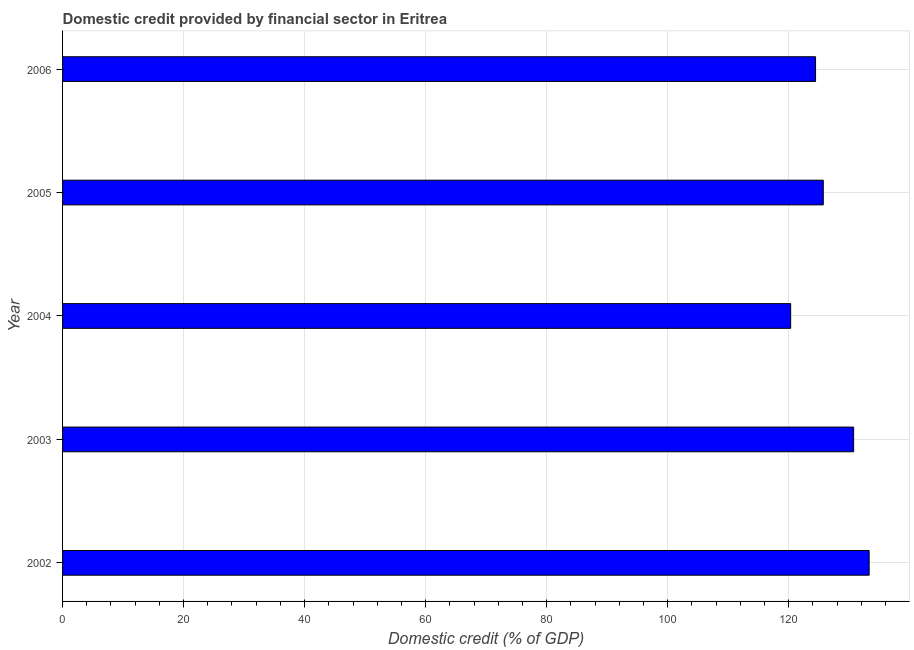Does the graph contain any zero values?
Give a very brief answer. No. Does the graph contain grids?
Your answer should be compact. Yes. What is the title of the graph?
Give a very brief answer. Domestic credit provided by financial sector in Eritrea. What is the label or title of the X-axis?
Your answer should be compact. Domestic credit (% of GDP). What is the domestic credit provided by financial sector in 2004?
Give a very brief answer. 120.34. Across all years, what is the maximum domestic credit provided by financial sector?
Provide a short and direct response. 133.31. Across all years, what is the minimum domestic credit provided by financial sector?
Give a very brief answer. 120.34. What is the sum of the domestic credit provided by financial sector?
Give a very brief answer. 634.56. What is the difference between the domestic credit provided by financial sector in 2003 and 2006?
Give a very brief answer. 6.29. What is the average domestic credit provided by financial sector per year?
Provide a succinct answer. 126.91. What is the median domestic credit provided by financial sector?
Your response must be concise. 125.73. In how many years, is the domestic credit provided by financial sector greater than 24 %?
Give a very brief answer. 5. What is the ratio of the domestic credit provided by financial sector in 2004 to that in 2006?
Provide a succinct answer. 0.97. Is the difference between the domestic credit provided by financial sector in 2003 and 2005 greater than the difference between any two years?
Keep it short and to the point. No. What is the difference between the highest and the second highest domestic credit provided by financial sector?
Provide a succinct answer. 2.56. Is the sum of the domestic credit provided by financial sector in 2004 and 2005 greater than the maximum domestic credit provided by financial sector across all years?
Give a very brief answer. Yes. What is the difference between the highest and the lowest domestic credit provided by financial sector?
Your answer should be very brief. 12.97. Are all the bars in the graph horizontal?
Ensure brevity in your answer.  Yes. How many years are there in the graph?
Offer a very short reply. 5. What is the difference between two consecutive major ticks on the X-axis?
Your answer should be very brief. 20. Are the values on the major ticks of X-axis written in scientific E-notation?
Provide a short and direct response. No. What is the Domestic credit (% of GDP) in 2002?
Give a very brief answer. 133.31. What is the Domestic credit (% of GDP) in 2003?
Your answer should be very brief. 130.74. What is the Domestic credit (% of GDP) of 2004?
Offer a terse response. 120.34. What is the Domestic credit (% of GDP) in 2005?
Make the answer very short. 125.73. What is the Domestic credit (% of GDP) of 2006?
Provide a succinct answer. 124.45. What is the difference between the Domestic credit (% of GDP) in 2002 and 2003?
Offer a very short reply. 2.56. What is the difference between the Domestic credit (% of GDP) in 2002 and 2004?
Ensure brevity in your answer.  12.97. What is the difference between the Domestic credit (% of GDP) in 2002 and 2005?
Provide a short and direct response. 7.58. What is the difference between the Domestic credit (% of GDP) in 2002 and 2006?
Your answer should be very brief. 8.86. What is the difference between the Domestic credit (% of GDP) in 2003 and 2004?
Give a very brief answer. 10.41. What is the difference between the Domestic credit (% of GDP) in 2003 and 2005?
Your answer should be compact. 5.02. What is the difference between the Domestic credit (% of GDP) in 2003 and 2006?
Your response must be concise. 6.29. What is the difference between the Domestic credit (% of GDP) in 2004 and 2005?
Provide a short and direct response. -5.39. What is the difference between the Domestic credit (% of GDP) in 2004 and 2006?
Give a very brief answer. -4.11. What is the difference between the Domestic credit (% of GDP) in 2005 and 2006?
Ensure brevity in your answer.  1.28. What is the ratio of the Domestic credit (% of GDP) in 2002 to that in 2003?
Make the answer very short. 1.02. What is the ratio of the Domestic credit (% of GDP) in 2002 to that in 2004?
Your answer should be compact. 1.11. What is the ratio of the Domestic credit (% of GDP) in 2002 to that in 2005?
Make the answer very short. 1.06. What is the ratio of the Domestic credit (% of GDP) in 2002 to that in 2006?
Provide a succinct answer. 1.07. What is the ratio of the Domestic credit (% of GDP) in 2003 to that in 2004?
Provide a succinct answer. 1.09. What is the ratio of the Domestic credit (% of GDP) in 2003 to that in 2005?
Make the answer very short. 1.04. What is the ratio of the Domestic credit (% of GDP) in 2003 to that in 2006?
Offer a very short reply. 1.05. What is the ratio of the Domestic credit (% of GDP) in 2004 to that in 2005?
Give a very brief answer. 0.96. What is the ratio of the Domestic credit (% of GDP) in 2004 to that in 2006?
Offer a terse response. 0.97. 